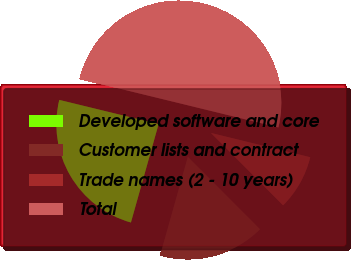<chart> <loc_0><loc_0><loc_500><loc_500><pie_chart><fcel>Developed software and core<fcel>Customer lists and contract<fcel>Trade names (2 - 10 years)<fcel>Total<nl><fcel>24.44%<fcel>16.84%<fcel>8.71%<fcel>50.01%<nl></chart> 